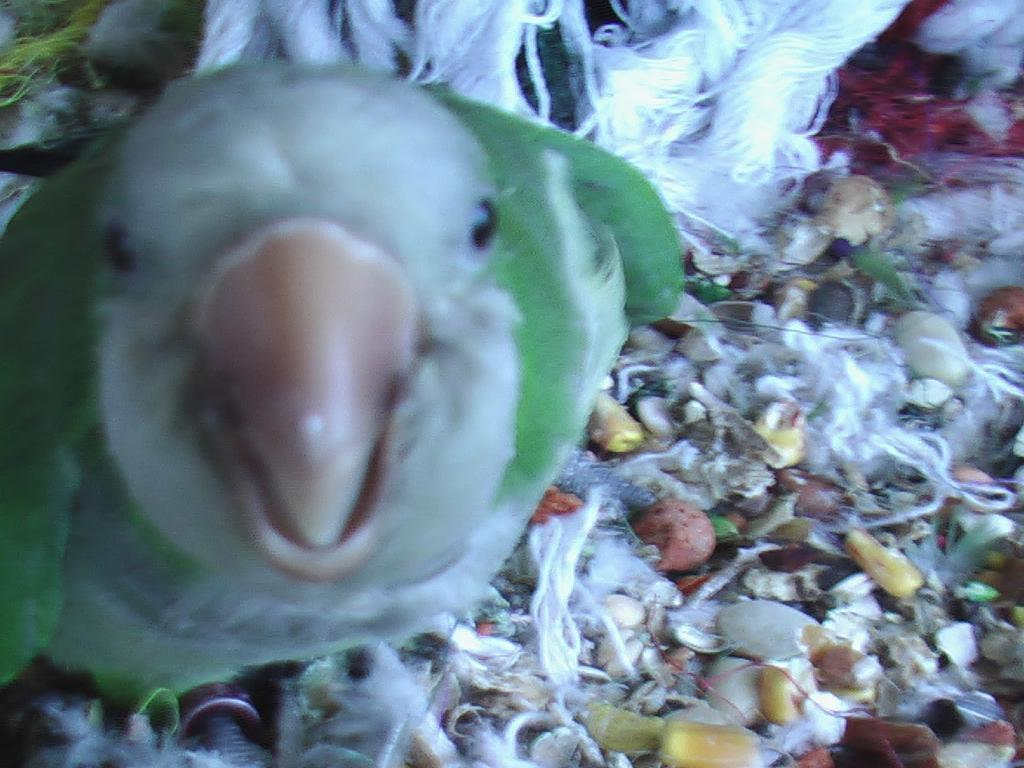What type of animal can be seen in the image? There is a bird in the image. What else is present in the image besides the bird? There are objects in the image. What type of border is present around the bird in the image? There is no border present around the bird in the image. What is the tendency of the bird to fly in the image? The image does not show the bird flying or provide information about its tendency to fly. 